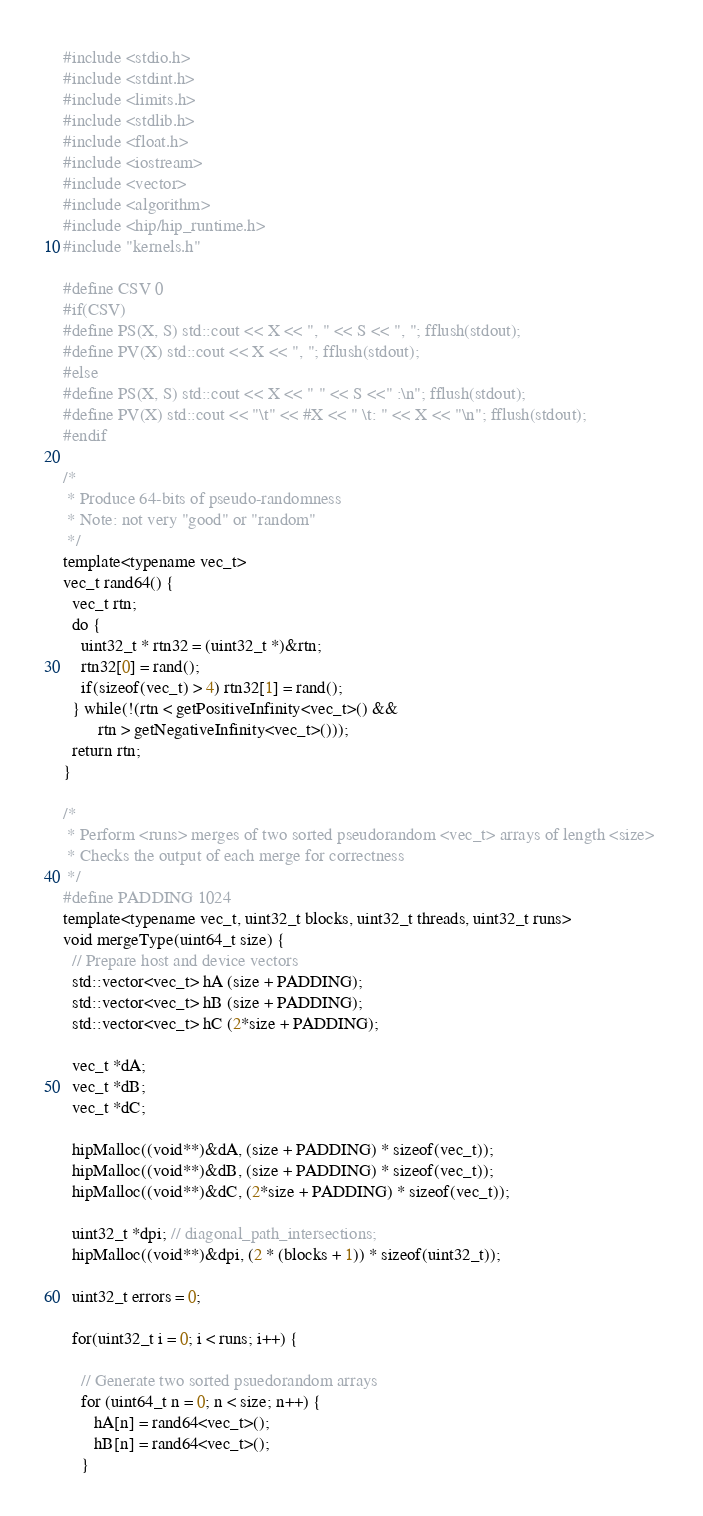<code> <loc_0><loc_0><loc_500><loc_500><_Cuda_>#include <stdio.h>
#include <stdint.h>
#include <limits.h>
#include <stdlib.h>
#include <float.h>
#include <iostream>
#include <vector>
#include <algorithm>
#include <hip/hip_runtime.h>
#include "kernels.h"

#define CSV 0
#if(CSV)
#define PS(X, S) std::cout << X << ", " << S << ", "; fflush(stdout);
#define PV(X) std::cout << X << ", "; fflush(stdout);
#else
#define PS(X, S) std::cout << X << " " << S <<" :\n"; fflush(stdout);
#define PV(X) std::cout << "\t" << #X << " \t: " << X << "\n"; fflush(stdout);
#endif

/*
 * Produce 64-bits of pseudo-randomness
 * Note: not very "good" or "random" 
 */
template<typename vec_t>
vec_t rand64() {
  vec_t rtn;
  do {
    uint32_t * rtn32 = (uint32_t *)&rtn;
    rtn32[0] = rand();
    if(sizeof(vec_t) > 4) rtn32[1] = rand();
  } while(!(rtn < getPositiveInfinity<vec_t>() &&
        rtn > getNegativeInfinity<vec_t>()));
  return rtn;
}

/*
 * Perform <runs> merges of two sorted pseudorandom <vec_t> arrays of length <size> 
 * Checks the output of each merge for correctness
 */
#define PADDING 1024
template<typename vec_t, uint32_t blocks, uint32_t threads, uint32_t runs>
void mergeType(uint64_t size) {
  // Prepare host and device vectors
  std::vector<vec_t> hA (size + PADDING);
  std::vector<vec_t> hB (size + PADDING);
  std::vector<vec_t> hC (2*size + PADDING);

  vec_t *dA;
  vec_t *dB;
  vec_t *dC;

  hipMalloc((void**)&dA, (size + PADDING) * sizeof(vec_t));
  hipMalloc((void**)&dB, (size + PADDING) * sizeof(vec_t));
  hipMalloc((void**)&dC, (2*size + PADDING) * sizeof(vec_t));

  uint32_t *dpi; // diagonal_path_intersections;
  hipMalloc((void**)&dpi, (2 * (blocks + 1)) * sizeof(uint32_t));

  uint32_t errors = 0;

  for(uint32_t i = 0; i < runs; i++) {

    // Generate two sorted psuedorandom arrays
    for (uint64_t n = 0; n < size; n++) {
       hA[n] = rand64<vec_t>();
       hB[n] = rand64<vec_t>();
    }
</code> 